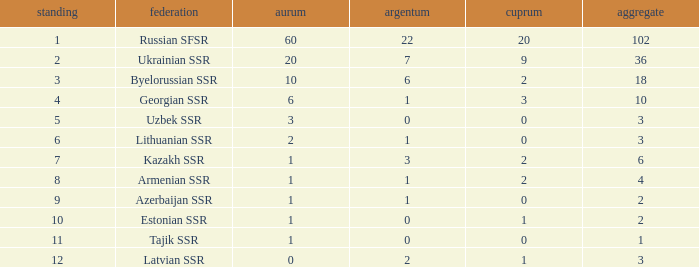What is the highest number of bronzes for teams ranked number 7 with more than 0 silver? 2.0. 